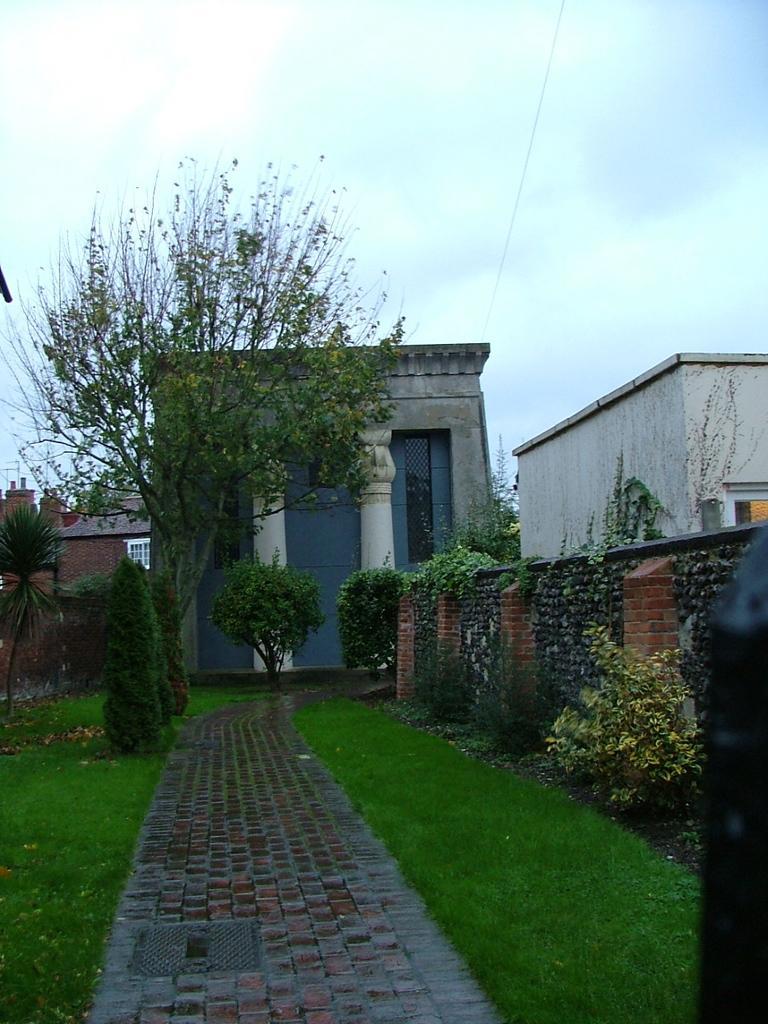Please provide a concise description of this image. In the center of the image we can see pillars and building. On the right side of the image we can see wall, building, trees, creepers and plants. On the left side of the image we can see tree, grass and plants. In the center of the image there is a walk way. In the background we can see sky and clouds. 